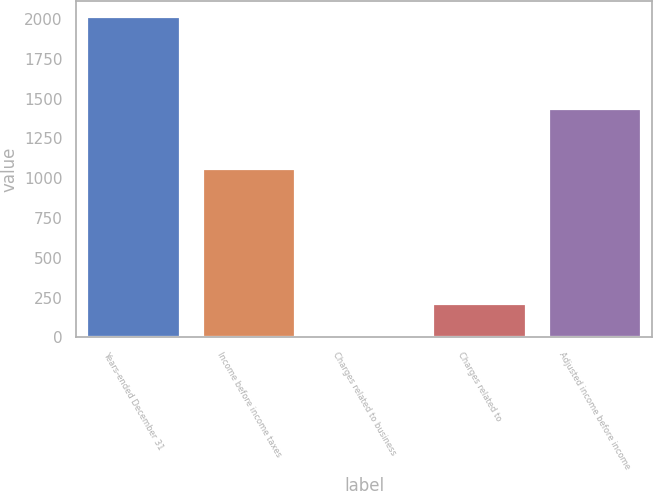<chart> <loc_0><loc_0><loc_500><loc_500><bar_chart><fcel>Years-ended December 31<fcel>Income before income taxes<fcel>Charges related to business<fcel>Charges related to<fcel>Adjusted income before income<nl><fcel>2012<fcel>1057<fcel>11<fcel>211.1<fcel>1435<nl></chart> 